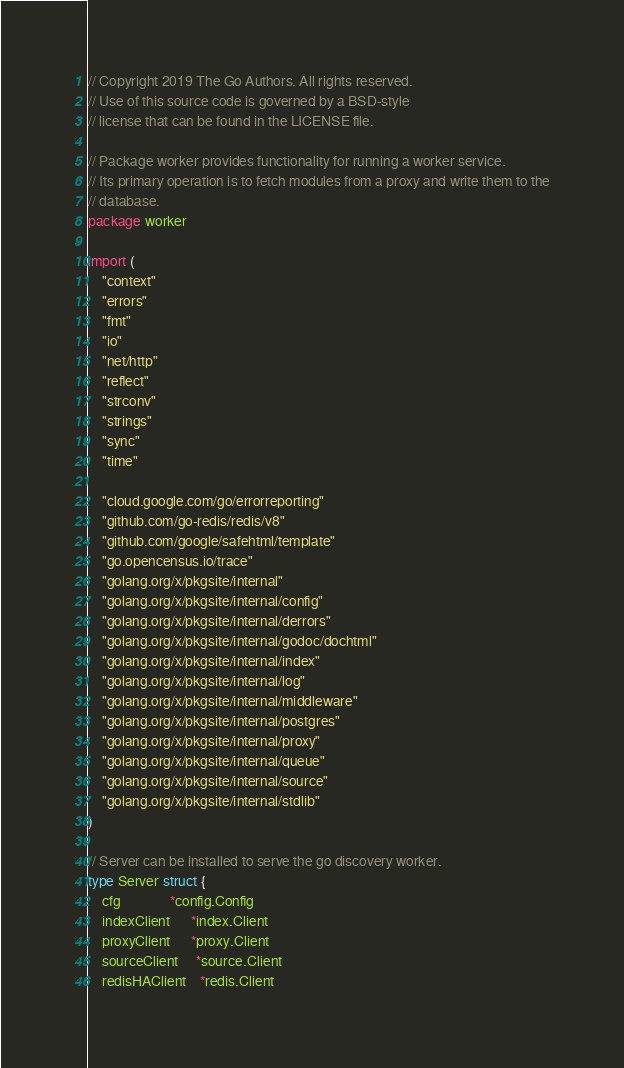<code> <loc_0><loc_0><loc_500><loc_500><_Go_>// Copyright 2019 The Go Authors. All rights reserved.
// Use of this source code is governed by a BSD-style
// license that can be found in the LICENSE file.

// Package worker provides functionality for running a worker service.
// Its primary operation is to fetch modules from a proxy and write them to the
// database.
package worker

import (
	"context"
	"errors"
	"fmt"
	"io"
	"net/http"
	"reflect"
	"strconv"
	"strings"
	"sync"
	"time"

	"cloud.google.com/go/errorreporting"
	"github.com/go-redis/redis/v8"
	"github.com/google/safehtml/template"
	"go.opencensus.io/trace"
	"golang.org/x/pkgsite/internal"
	"golang.org/x/pkgsite/internal/config"
	"golang.org/x/pkgsite/internal/derrors"
	"golang.org/x/pkgsite/internal/godoc/dochtml"
	"golang.org/x/pkgsite/internal/index"
	"golang.org/x/pkgsite/internal/log"
	"golang.org/x/pkgsite/internal/middleware"
	"golang.org/x/pkgsite/internal/postgres"
	"golang.org/x/pkgsite/internal/proxy"
	"golang.org/x/pkgsite/internal/queue"
	"golang.org/x/pkgsite/internal/source"
	"golang.org/x/pkgsite/internal/stdlib"
)

// Server can be installed to serve the go discovery worker.
type Server struct {
	cfg              *config.Config
	indexClient      *index.Client
	proxyClient      *proxy.Client
	sourceClient     *source.Client
	redisHAClient    *redis.Client</code> 